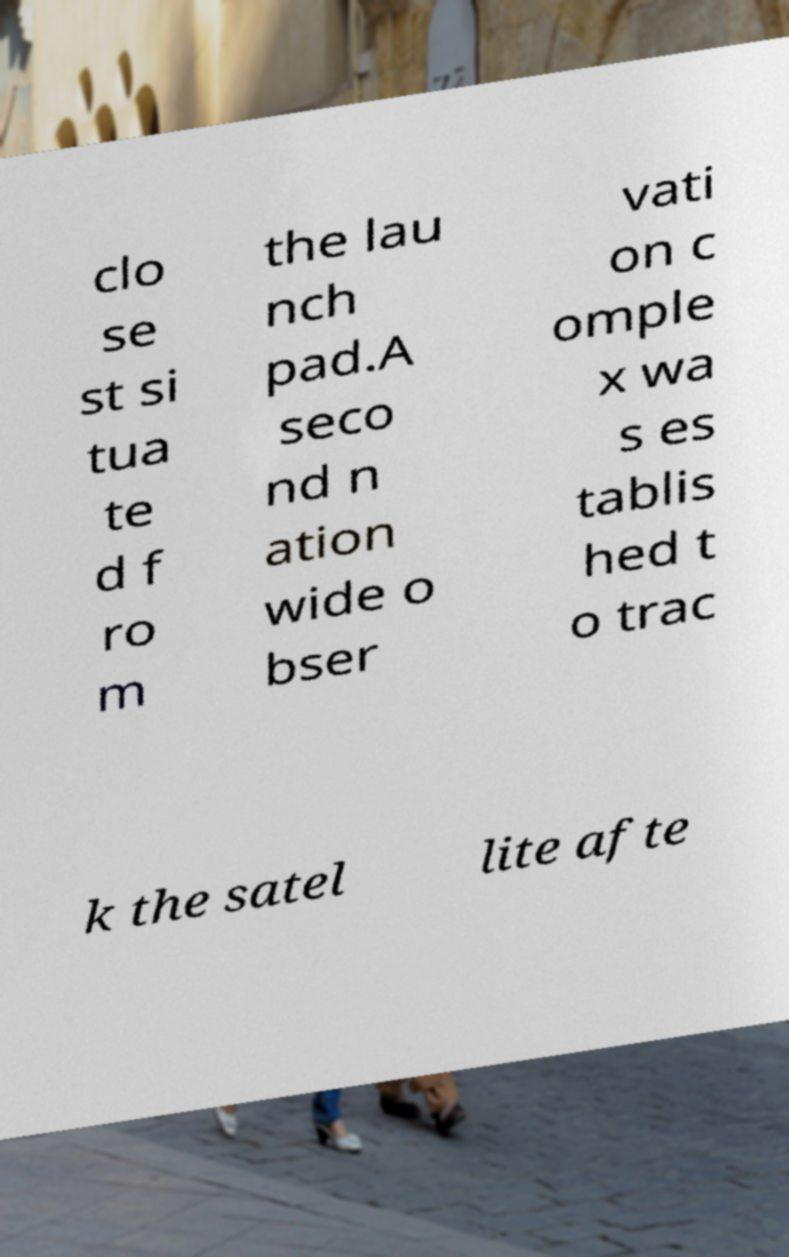Please identify and transcribe the text found in this image. clo se st si tua te d f ro m the lau nch pad.A seco nd n ation wide o bser vati on c omple x wa s es tablis hed t o trac k the satel lite afte 